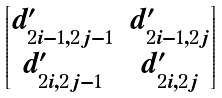Convert formula to latex. <formula><loc_0><loc_0><loc_500><loc_500>\begin{bmatrix} d ^ { \prime } _ { 2 i - 1 , 2 j - 1 } & d ^ { \prime } _ { 2 i - 1 , 2 j } \\ d ^ { \prime } _ { 2 i , 2 j - 1 } & d ^ { \prime } _ { 2 i , 2 j } \end{bmatrix}</formula> 